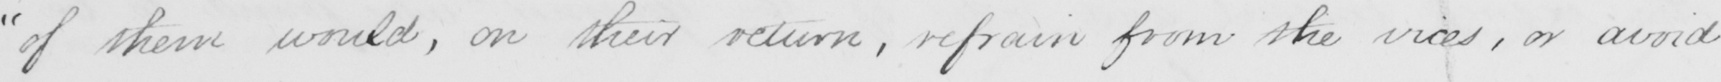What text is written in this handwritten line? " of them would , on their return , refrain from the vices , or avoid 